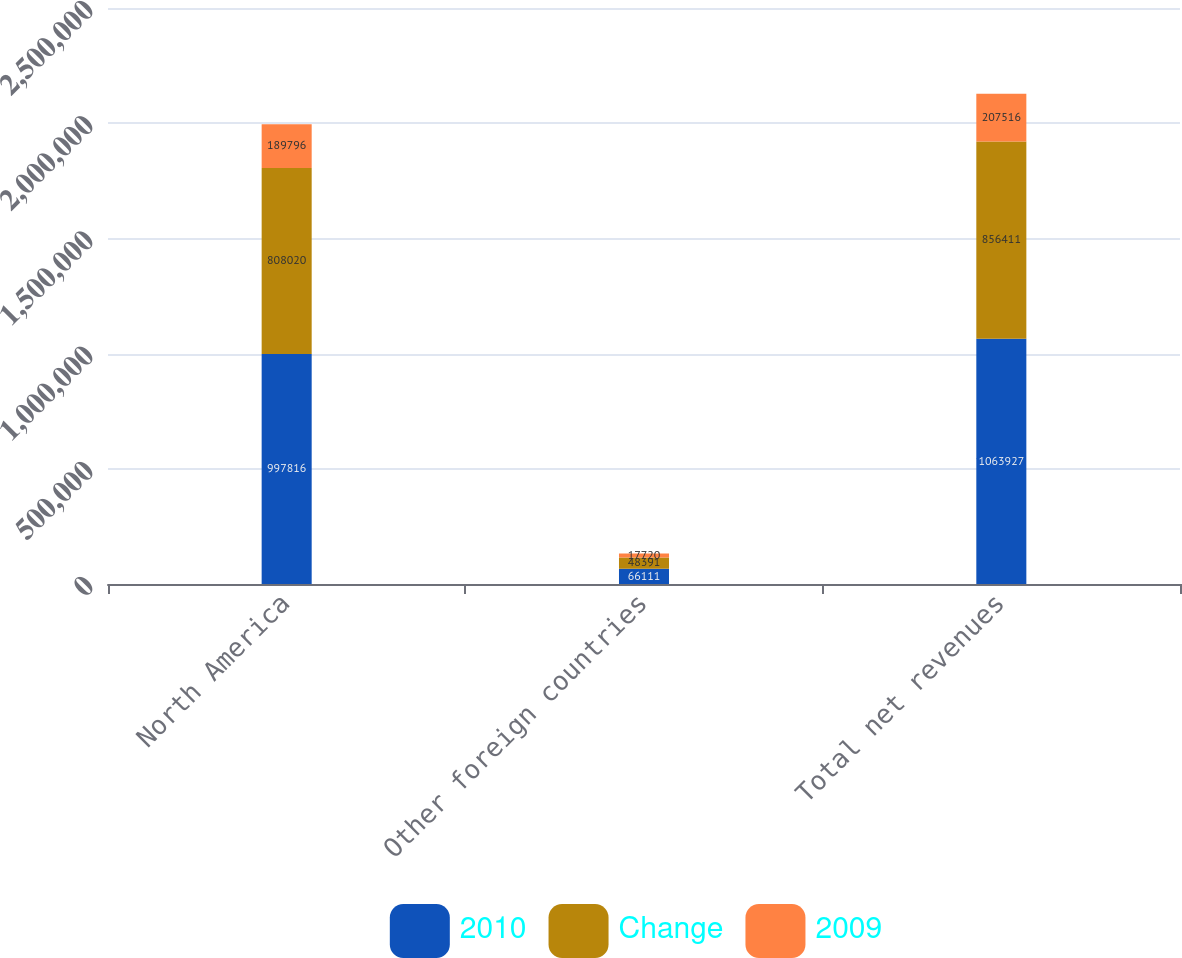Convert chart. <chart><loc_0><loc_0><loc_500><loc_500><stacked_bar_chart><ecel><fcel>North America<fcel>Other foreign countries<fcel>Total net revenues<nl><fcel>2010<fcel>997816<fcel>66111<fcel>1.06393e+06<nl><fcel>Change<fcel>808020<fcel>48391<fcel>856411<nl><fcel>2009<fcel>189796<fcel>17720<fcel>207516<nl></chart> 